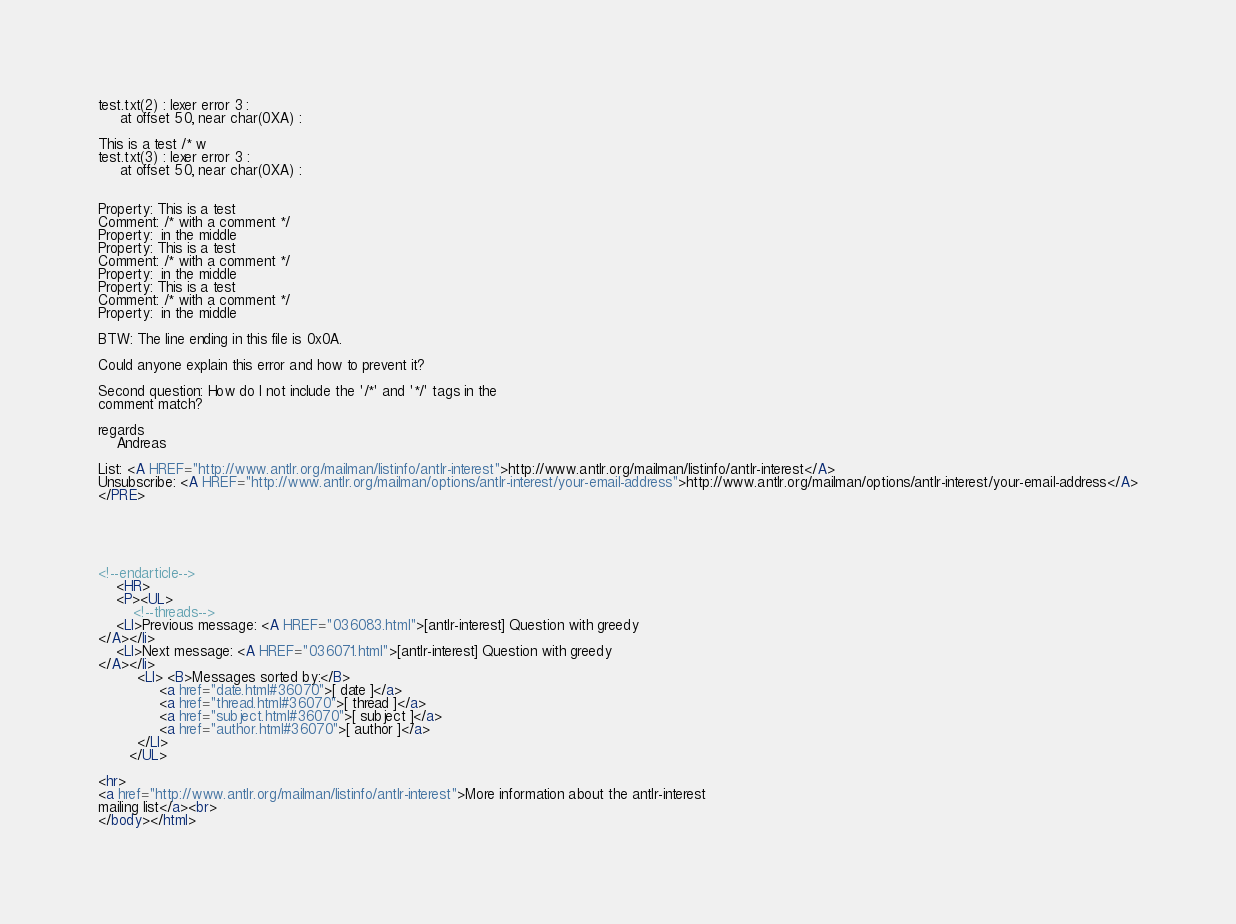<code> <loc_0><loc_0><loc_500><loc_500><_HTML_>test.txt(2) : lexer error 3 :
	 at offset 50, near char(0XA) :
	
This is a test /* w
test.txt(3) : lexer error 3 :
	 at offset 50, near char(0XA) :
	

Property: This is a test 
Comment: /* with a comment */
Property:  in the middle
Property: This is a test 
Comment: /* with a comment */
Property:  in the middle
Property: This is a test 
Comment: /* with a comment */
Property:  in the middle

BTW: The line ending in this file is 0x0A.

Could anyone explain this error and how to prevent it?

Second question: How do I not include the '/*' and '*/' tags in the
comment match?

regards
	Andreas

List: <A HREF="http://www.antlr.org/mailman/listinfo/antlr-interest">http://www.antlr.org/mailman/listinfo/antlr-interest</A>
Unsubscribe: <A HREF="http://www.antlr.org/mailman/options/antlr-interest/your-email-address">http://www.antlr.org/mailman/options/antlr-interest/your-email-address</A>
</PRE>





<!--endarticle-->
    <HR>
    <P><UL>
        <!--threads-->
	<LI>Previous message: <A HREF="036083.html">[antlr-interest] Question with greedy
</A></li>
	<LI>Next message: <A HREF="036071.html">[antlr-interest] Question with greedy
</A></li>
         <LI> <B>Messages sorted by:</B> 
              <a href="date.html#36070">[ date ]</a>
              <a href="thread.html#36070">[ thread ]</a>
              <a href="subject.html#36070">[ subject ]</a>
              <a href="author.html#36070">[ author ]</a>
         </LI>
       </UL>

<hr>
<a href="http://www.antlr.org/mailman/listinfo/antlr-interest">More information about the antlr-interest
mailing list</a><br>
</body></html>
</code> 